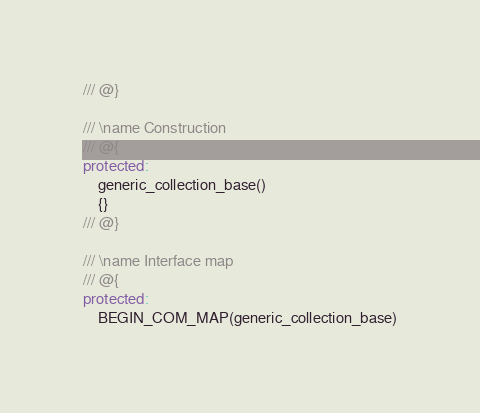Convert code to text. <code><loc_0><loc_0><loc_500><loc_500><_C++_>/// @}

/// \name Construction
/// @{
protected:
    generic_collection_base()
    {}
/// @}

/// \name Interface map
/// @{
protected:
    BEGIN_COM_MAP(generic_collection_base)</code> 